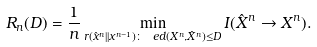<formula> <loc_0><loc_0><loc_500><loc_500>R _ { n } ( D ) = \frac { 1 } { n } \min _ { r ( \hat { x } ^ { n } | | x ^ { n - 1 } ) \colon \ e { d ( X ^ { n } , \hat { X } ^ { n } ) } \leq D } I ( \hat { X } ^ { n } \rightarrow X ^ { n } ) .</formula> 